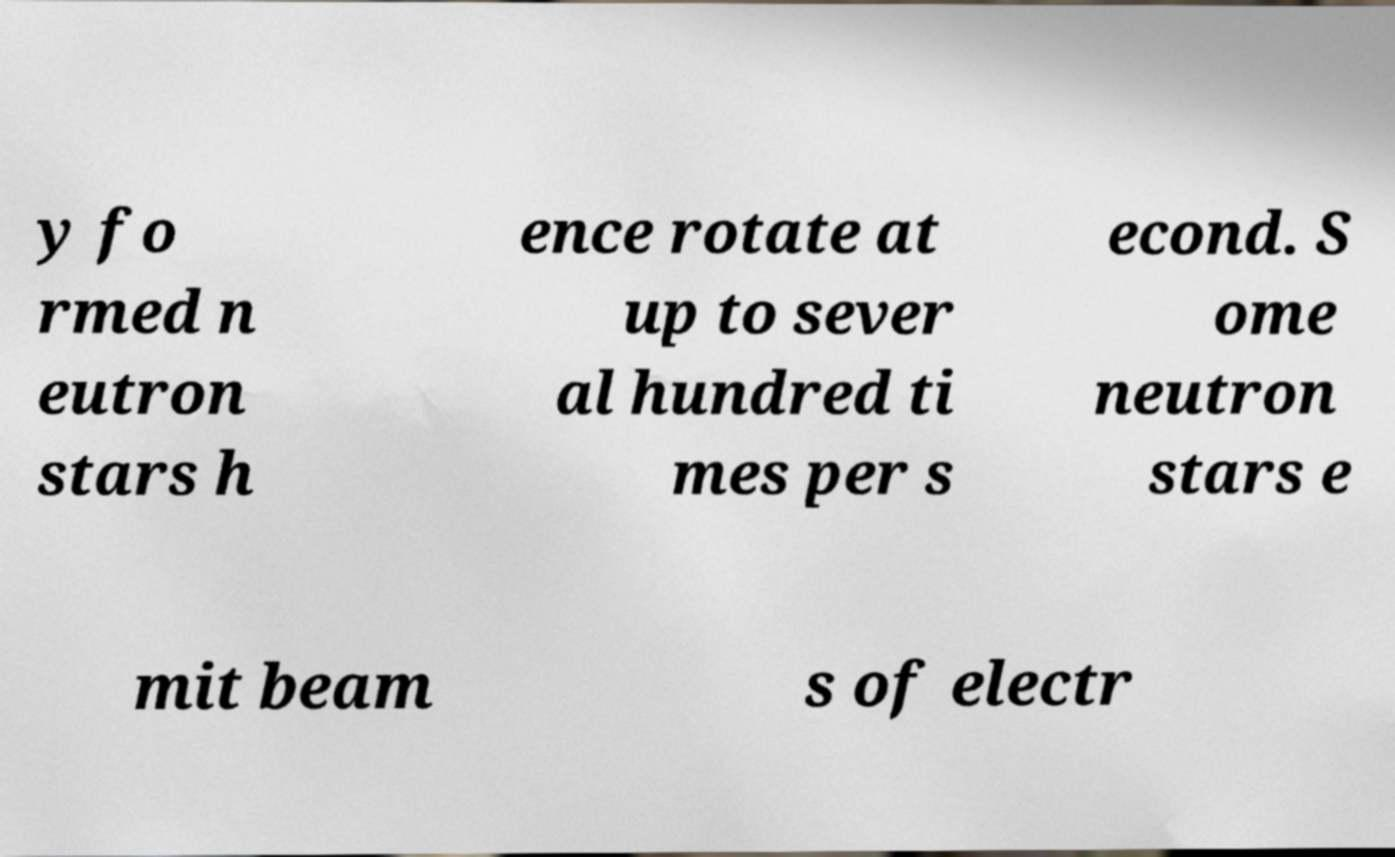What messages or text are displayed in this image? I need them in a readable, typed format. y fo rmed n eutron stars h ence rotate at up to sever al hundred ti mes per s econd. S ome neutron stars e mit beam s of electr 